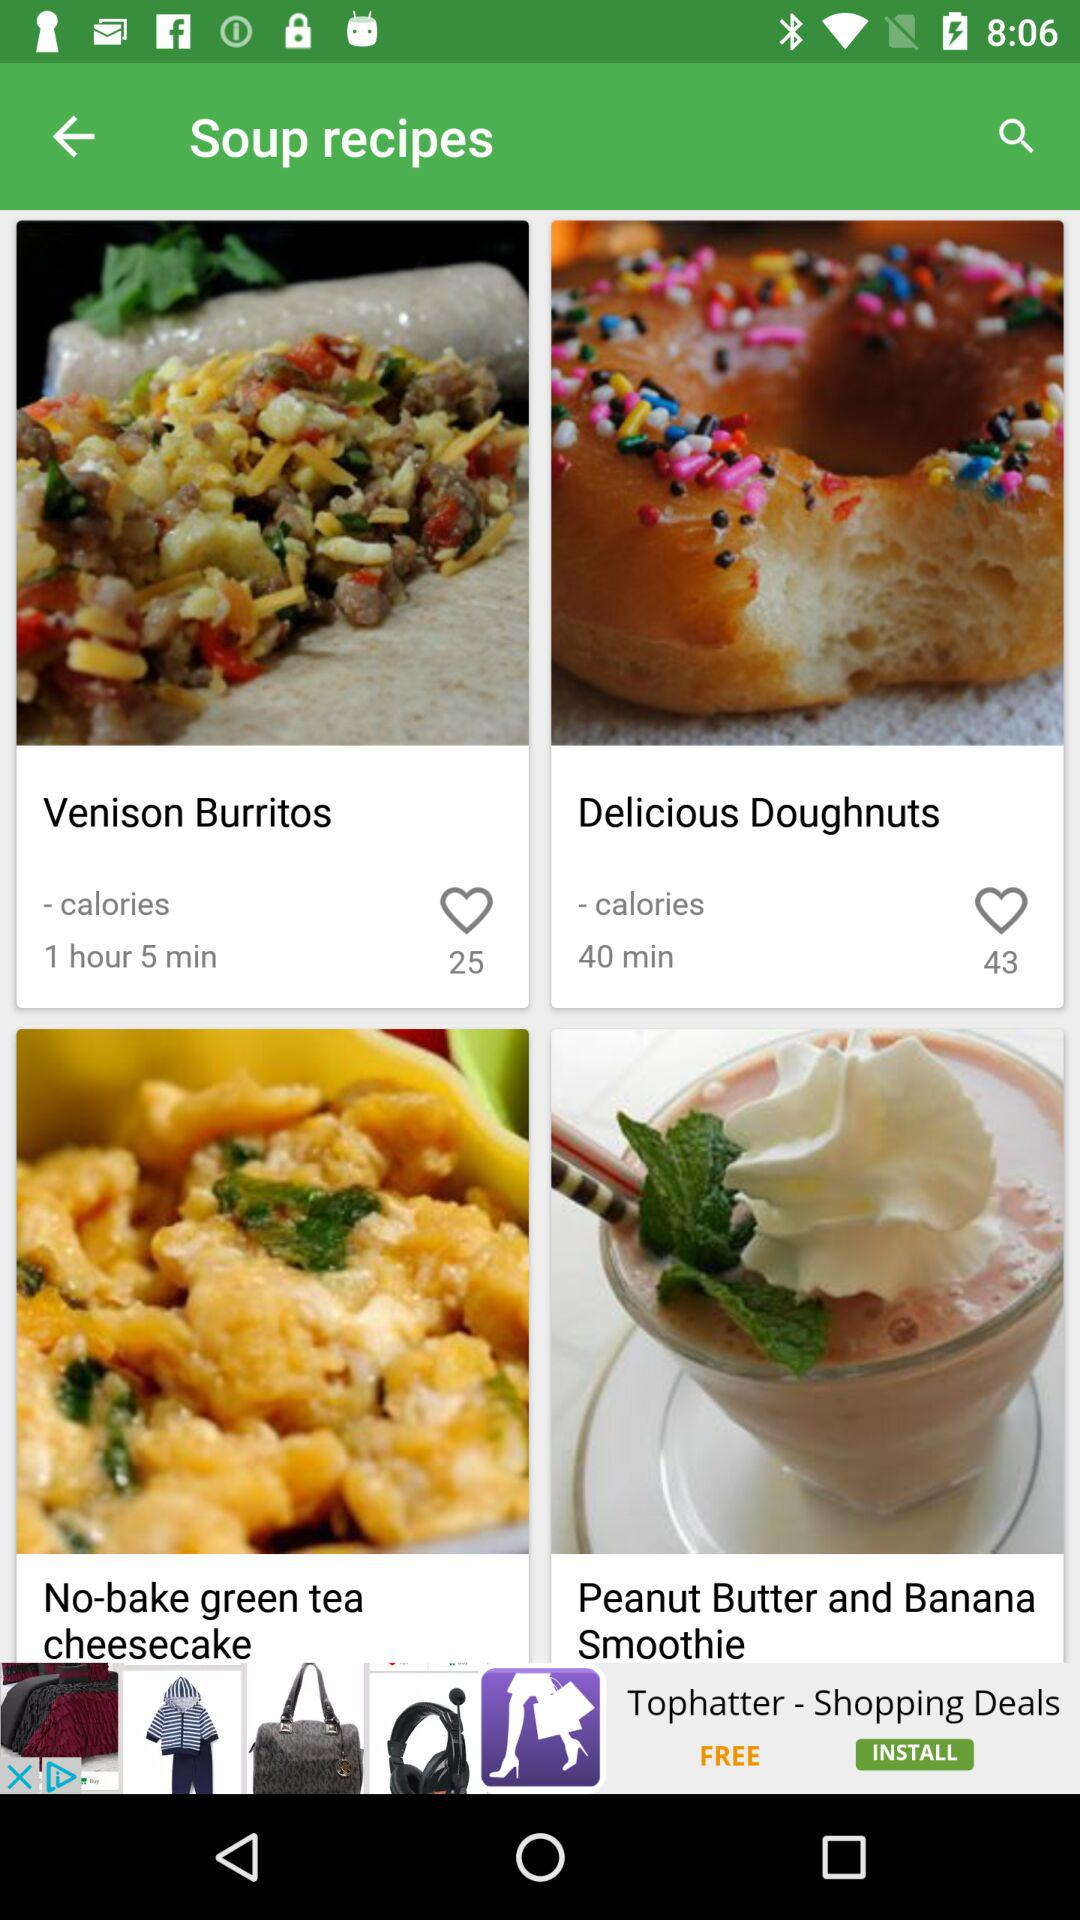How many likes are there for "Venison Burritos"? There are 25 likes. 